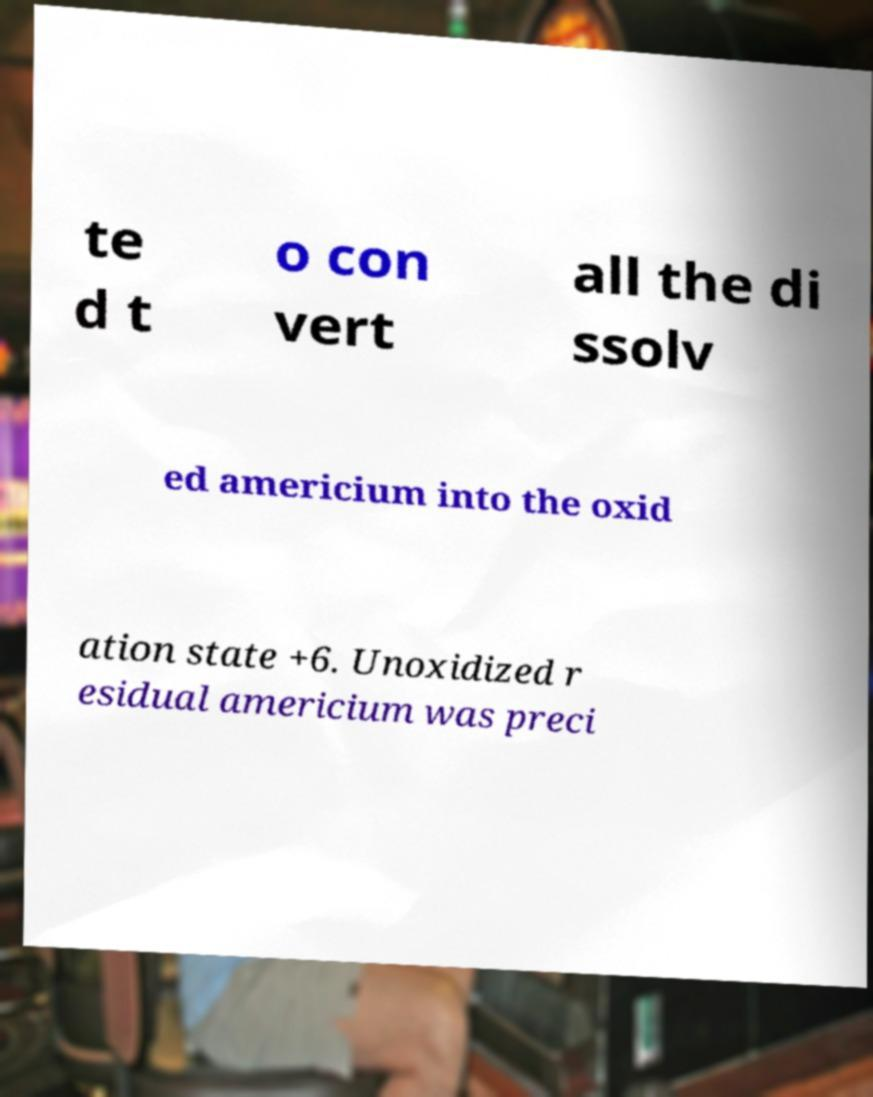Could you assist in decoding the text presented in this image and type it out clearly? te d t o con vert all the di ssolv ed americium into the oxid ation state +6. Unoxidized r esidual americium was preci 